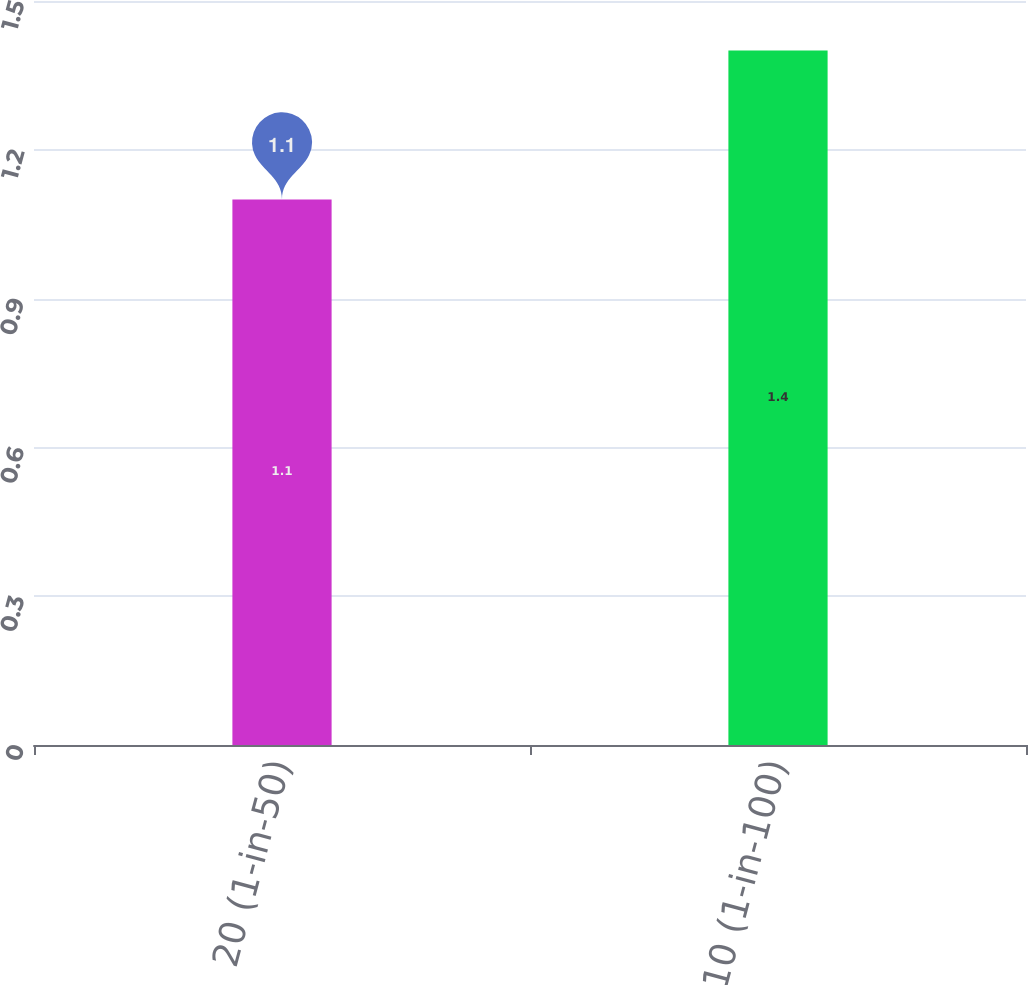Convert chart. <chart><loc_0><loc_0><loc_500><loc_500><bar_chart><fcel>20 (1-in-50)<fcel>10 (1-in-100)<nl><fcel>1.1<fcel>1.4<nl></chart> 